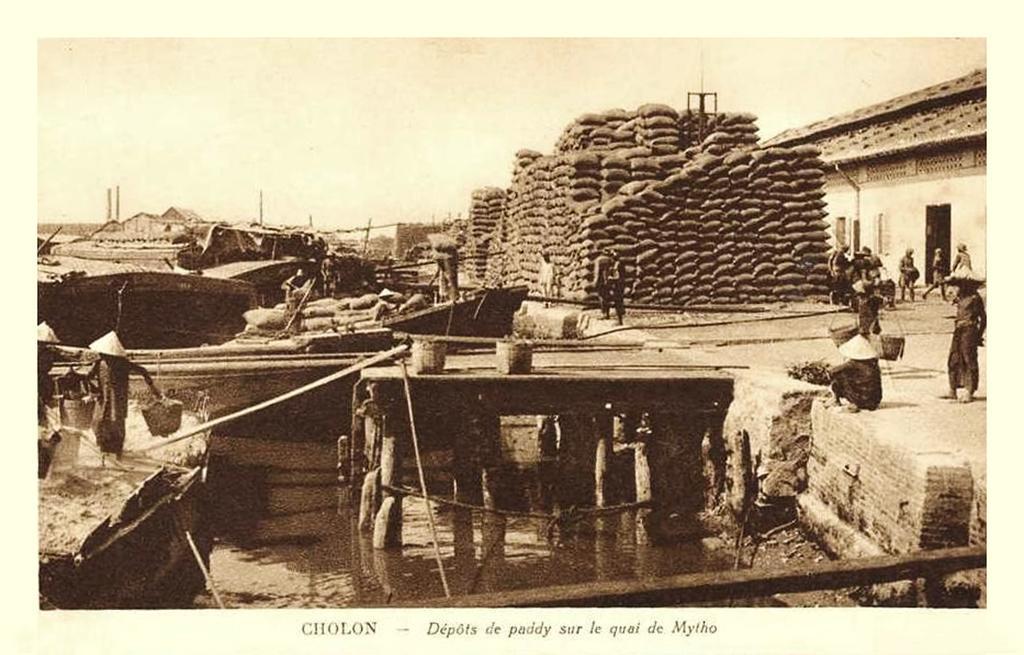Can you describe this image briefly? In this image we can see the houses, people and also the load of gully bags on the path. We can also see the bridge, boats, sticks and also the water. At the bottom we can see the text. Sky is also visible. 